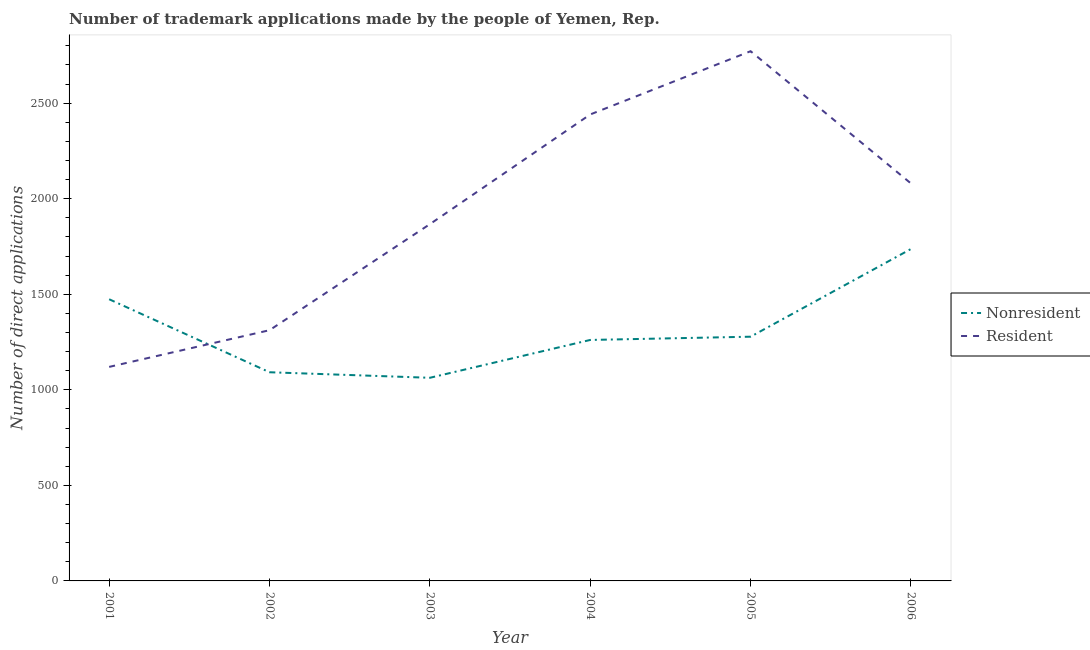How many different coloured lines are there?
Offer a terse response. 2. What is the number of trademark applications made by non residents in 2004?
Give a very brief answer. 1261. Across all years, what is the maximum number of trademark applications made by non residents?
Provide a short and direct response. 1737. Across all years, what is the minimum number of trademark applications made by residents?
Keep it short and to the point. 1120. What is the total number of trademark applications made by residents in the graph?
Your answer should be compact. 1.16e+04. What is the difference between the number of trademark applications made by residents in 2002 and that in 2005?
Provide a short and direct response. -1460. What is the difference between the number of trademark applications made by residents in 2006 and the number of trademark applications made by non residents in 2001?
Make the answer very short. 606. What is the average number of trademark applications made by non residents per year?
Keep it short and to the point. 1317.5. In the year 2003, what is the difference between the number of trademark applications made by non residents and number of trademark applications made by residents?
Keep it short and to the point. -804. In how many years, is the number of trademark applications made by non residents greater than 1500?
Ensure brevity in your answer.  1. What is the ratio of the number of trademark applications made by non residents in 2001 to that in 2005?
Provide a succinct answer. 1.15. Is the number of trademark applications made by residents in 2001 less than that in 2003?
Offer a terse response. Yes. What is the difference between the highest and the second highest number of trademark applications made by non residents?
Your answer should be compact. 263. What is the difference between the highest and the lowest number of trademark applications made by non residents?
Give a very brief answer. 674. Does the number of trademark applications made by non residents monotonically increase over the years?
Keep it short and to the point. No. How many lines are there?
Provide a short and direct response. 2. How many years are there in the graph?
Your answer should be compact. 6. What is the difference between two consecutive major ticks on the Y-axis?
Your response must be concise. 500. How many legend labels are there?
Provide a short and direct response. 2. What is the title of the graph?
Offer a very short reply. Number of trademark applications made by the people of Yemen, Rep. What is the label or title of the X-axis?
Keep it short and to the point. Year. What is the label or title of the Y-axis?
Ensure brevity in your answer.  Number of direct applications. What is the Number of direct applications in Nonresident in 2001?
Give a very brief answer. 1474. What is the Number of direct applications in Resident in 2001?
Keep it short and to the point. 1120. What is the Number of direct applications of Nonresident in 2002?
Give a very brief answer. 1092. What is the Number of direct applications in Resident in 2002?
Your response must be concise. 1312. What is the Number of direct applications of Nonresident in 2003?
Provide a short and direct response. 1063. What is the Number of direct applications of Resident in 2003?
Ensure brevity in your answer.  1867. What is the Number of direct applications in Nonresident in 2004?
Offer a very short reply. 1261. What is the Number of direct applications in Resident in 2004?
Give a very brief answer. 2441. What is the Number of direct applications in Nonresident in 2005?
Your response must be concise. 1278. What is the Number of direct applications of Resident in 2005?
Offer a very short reply. 2772. What is the Number of direct applications of Nonresident in 2006?
Offer a very short reply. 1737. What is the Number of direct applications in Resident in 2006?
Your answer should be compact. 2080. Across all years, what is the maximum Number of direct applications in Nonresident?
Keep it short and to the point. 1737. Across all years, what is the maximum Number of direct applications in Resident?
Provide a short and direct response. 2772. Across all years, what is the minimum Number of direct applications in Nonresident?
Provide a short and direct response. 1063. Across all years, what is the minimum Number of direct applications in Resident?
Offer a terse response. 1120. What is the total Number of direct applications of Nonresident in the graph?
Provide a succinct answer. 7905. What is the total Number of direct applications of Resident in the graph?
Give a very brief answer. 1.16e+04. What is the difference between the Number of direct applications of Nonresident in 2001 and that in 2002?
Provide a succinct answer. 382. What is the difference between the Number of direct applications of Resident in 2001 and that in 2002?
Provide a succinct answer. -192. What is the difference between the Number of direct applications in Nonresident in 2001 and that in 2003?
Offer a very short reply. 411. What is the difference between the Number of direct applications of Resident in 2001 and that in 2003?
Provide a succinct answer. -747. What is the difference between the Number of direct applications of Nonresident in 2001 and that in 2004?
Keep it short and to the point. 213. What is the difference between the Number of direct applications in Resident in 2001 and that in 2004?
Offer a terse response. -1321. What is the difference between the Number of direct applications of Nonresident in 2001 and that in 2005?
Your answer should be very brief. 196. What is the difference between the Number of direct applications of Resident in 2001 and that in 2005?
Provide a short and direct response. -1652. What is the difference between the Number of direct applications of Nonresident in 2001 and that in 2006?
Your answer should be compact. -263. What is the difference between the Number of direct applications in Resident in 2001 and that in 2006?
Make the answer very short. -960. What is the difference between the Number of direct applications of Nonresident in 2002 and that in 2003?
Offer a terse response. 29. What is the difference between the Number of direct applications in Resident in 2002 and that in 2003?
Your response must be concise. -555. What is the difference between the Number of direct applications of Nonresident in 2002 and that in 2004?
Keep it short and to the point. -169. What is the difference between the Number of direct applications in Resident in 2002 and that in 2004?
Provide a succinct answer. -1129. What is the difference between the Number of direct applications of Nonresident in 2002 and that in 2005?
Make the answer very short. -186. What is the difference between the Number of direct applications in Resident in 2002 and that in 2005?
Give a very brief answer. -1460. What is the difference between the Number of direct applications of Nonresident in 2002 and that in 2006?
Make the answer very short. -645. What is the difference between the Number of direct applications in Resident in 2002 and that in 2006?
Your response must be concise. -768. What is the difference between the Number of direct applications in Nonresident in 2003 and that in 2004?
Ensure brevity in your answer.  -198. What is the difference between the Number of direct applications in Resident in 2003 and that in 2004?
Offer a very short reply. -574. What is the difference between the Number of direct applications in Nonresident in 2003 and that in 2005?
Your answer should be very brief. -215. What is the difference between the Number of direct applications of Resident in 2003 and that in 2005?
Provide a succinct answer. -905. What is the difference between the Number of direct applications of Nonresident in 2003 and that in 2006?
Provide a short and direct response. -674. What is the difference between the Number of direct applications of Resident in 2003 and that in 2006?
Your answer should be very brief. -213. What is the difference between the Number of direct applications of Nonresident in 2004 and that in 2005?
Give a very brief answer. -17. What is the difference between the Number of direct applications in Resident in 2004 and that in 2005?
Give a very brief answer. -331. What is the difference between the Number of direct applications in Nonresident in 2004 and that in 2006?
Keep it short and to the point. -476. What is the difference between the Number of direct applications in Resident in 2004 and that in 2006?
Ensure brevity in your answer.  361. What is the difference between the Number of direct applications of Nonresident in 2005 and that in 2006?
Your answer should be compact. -459. What is the difference between the Number of direct applications in Resident in 2005 and that in 2006?
Give a very brief answer. 692. What is the difference between the Number of direct applications in Nonresident in 2001 and the Number of direct applications in Resident in 2002?
Make the answer very short. 162. What is the difference between the Number of direct applications of Nonresident in 2001 and the Number of direct applications of Resident in 2003?
Provide a succinct answer. -393. What is the difference between the Number of direct applications of Nonresident in 2001 and the Number of direct applications of Resident in 2004?
Your response must be concise. -967. What is the difference between the Number of direct applications in Nonresident in 2001 and the Number of direct applications in Resident in 2005?
Provide a short and direct response. -1298. What is the difference between the Number of direct applications of Nonresident in 2001 and the Number of direct applications of Resident in 2006?
Offer a terse response. -606. What is the difference between the Number of direct applications in Nonresident in 2002 and the Number of direct applications in Resident in 2003?
Your answer should be very brief. -775. What is the difference between the Number of direct applications of Nonresident in 2002 and the Number of direct applications of Resident in 2004?
Offer a terse response. -1349. What is the difference between the Number of direct applications in Nonresident in 2002 and the Number of direct applications in Resident in 2005?
Make the answer very short. -1680. What is the difference between the Number of direct applications of Nonresident in 2002 and the Number of direct applications of Resident in 2006?
Keep it short and to the point. -988. What is the difference between the Number of direct applications of Nonresident in 2003 and the Number of direct applications of Resident in 2004?
Your response must be concise. -1378. What is the difference between the Number of direct applications of Nonresident in 2003 and the Number of direct applications of Resident in 2005?
Provide a short and direct response. -1709. What is the difference between the Number of direct applications of Nonresident in 2003 and the Number of direct applications of Resident in 2006?
Offer a very short reply. -1017. What is the difference between the Number of direct applications in Nonresident in 2004 and the Number of direct applications in Resident in 2005?
Offer a terse response. -1511. What is the difference between the Number of direct applications of Nonresident in 2004 and the Number of direct applications of Resident in 2006?
Offer a terse response. -819. What is the difference between the Number of direct applications of Nonresident in 2005 and the Number of direct applications of Resident in 2006?
Provide a succinct answer. -802. What is the average Number of direct applications in Nonresident per year?
Keep it short and to the point. 1317.5. What is the average Number of direct applications in Resident per year?
Provide a short and direct response. 1932. In the year 2001, what is the difference between the Number of direct applications of Nonresident and Number of direct applications of Resident?
Your answer should be very brief. 354. In the year 2002, what is the difference between the Number of direct applications in Nonresident and Number of direct applications in Resident?
Make the answer very short. -220. In the year 2003, what is the difference between the Number of direct applications of Nonresident and Number of direct applications of Resident?
Make the answer very short. -804. In the year 2004, what is the difference between the Number of direct applications in Nonresident and Number of direct applications in Resident?
Provide a succinct answer. -1180. In the year 2005, what is the difference between the Number of direct applications in Nonresident and Number of direct applications in Resident?
Provide a short and direct response. -1494. In the year 2006, what is the difference between the Number of direct applications of Nonresident and Number of direct applications of Resident?
Offer a very short reply. -343. What is the ratio of the Number of direct applications in Nonresident in 2001 to that in 2002?
Provide a succinct answer. 1.35. What is the ratio of the Number of direct applications of Resident in 2001 to that in 2002?
Ensure brevity in your answer.  0.85. What is the ratio of the Number of direct applications of Nonresident in 2001 to that in 2003?
Ensure brevity in your answer.  1.39. What is the ratio of the Number of direct applications in Resident in 2001 to that in 2003?
Your answer should be compact. 0.6. What is the ratio of the Number of direct applications of Nonresident in 2001 to that in 2004?
Offer a very short reply. 1.17. What is the ratio of the Number of direct applications of Resident in 2001 to that in 2004?
Keep it short and to the point. 0.46. What is the ratio of the Number of direct applications of Nonresident in 2001 to that in 2005?
Ensure brevity in your answer.  1.15. What is the ratio of the Number of direct applications in Resident in 2001 to that in 2005?
Make the answer very short. 0.4. What is the ratio of the Number of direct applications of Nonresident in 2001 to that in 2006?
Your answer should be very brief. 0.85. What is the ratio of the Number of direct applications of Resident in 2001 to that in 2006?
Provide a succinct answer. 0.54. What is the ratio of the Number of direct applications in Nonresident in 2002 to that in 2003?
Your answer should be compact. 1.03. What is the ratio of the Number of direct applications of Resident in 2002 to that in 2003?
Your answer should be very brief. 0.7. What is the ratio of the Number of direct applications in Nonresident in 2002 to that in 2004?
Provide a succinct answer. 0.87. What is the ratio of the Number of direct applications in Resident in 2002 to that in 2004?
Your answer should be compact. 0.54. What is the ratio of the Number of direct applications in Nonresident in 2002 to that in 2005?
Make the answer very short. 0.85. What is the ratio of the Number of direct applications in Resident in 2002 to that in 2005?
Your answer should be compact. 0.47. What is the ratio of the Number of direct applications in Nonresident in 2002 to that in 2006?
Give a very brief answer. 0.63. What is the ratio of the Number of direct applications in Resident in 2002 to that in 2006?
Provide a short and direct response. 0.63. What is the ratio of the Number of direct applications of Nonresident in 2003 to that in 2004?
Ensure brevity in your answer.  0.84. What is the ratio of the Number of direct applications in Resident in 2003 to that in 2004?
Your response must be concise. 0.76. What is the ratio of the Number of direct applications in Nonresident in 2003 to that in 2005?
Provide a succinct answer. 0.83. What is the ratio of the Number of direct applications in Resident in 2003 to that in 2005?
Provide a succinct answer. 0.67. What is the ratio of the Number of direct applications of Nonresident in 2003 to that in 2006?
Your response must be concise. 0.61. What is the ratio of the Number of direct applications in Resident in 2003 to that in 2006?
Your answer should be very brief. 0.9. What is the ratio of the Number of direct applications of Nonresident in 2004 to that in 2005?
Provide a short and direct response. 0.99. What is the ratio of the Number of direct applications of Resident in 2004 to that in 2005?
Offer a terse response. 0.88. What is the ratio of the Number of direct applications in Nonresident in 2004 to that in 2006?
Make the answer very short. 0.73. What is the ratio of the Number of direct applications of Resident in 2004 to that in 2006?
Your answer should be very brief. 1.17. What is the ratio of the Number of direct applications in Nonresident in 2005 to that in 2006?
Offer a very short reply. 0.74. What is the ratio of the Number of direct applications in Resident in 2005 to that in 2006?
Offer a very short reply. 1.33. What is the difference between the highest and the second highest Number of direct applications in Nonresident?
Your response must be concise. 263. What is the difference between the highest and the second highest Number of direct applications of Resident?
Keep it short and to the point. 331. What is the difference between the highest and the lowest Number of direct applications of Nonresident?
Your answer should be very brief. 674. What is the difference between the highest and the lowest Number of direct applications of Resident?
Ensure brevity in your answer.  1652. 